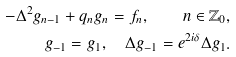<formula> <loc_0><loc_0><loc_500><loc_500>- \Delta ^ { 2 } g _ { n - 1 } + q _ { n } g _ { n } = f _ { n } , \quad n \in \mathbb { Z } _ { 0 } , \\ g _ { - 1 } = g _ { 1 } , \quad \Delta g _ { - 1 } = e ^ { 2 i \delta } \Delta g _ { 1 } .</formula> 